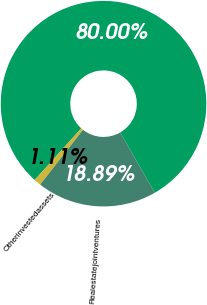<chart> <loc_0><loc_0><loc_500><loc_500><pie_chart><ecel><fcel>Otherinvestedassets<fcel>Realestatejointventures<nl><fcel>80.0%<fcel>1.11%<fcel>18.89%<nl></chart> 